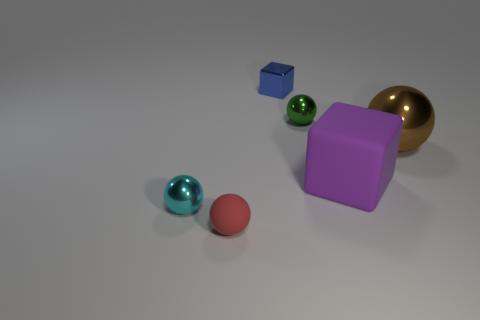Add 2 small cyan metallic balls. How many objects exist? 8 Subtract all blocks. How many objects are left? 4 Add 3 red matte spheres. How many red matte spheres exist? 4 Subtract 0 green cubes. How many objects are left? 6 Subtract all green metallic objects. Subtract all big purple matte objects. How many objects are left? 4 Add 2 green shiny balls. How many green shiny balls are left? 3 